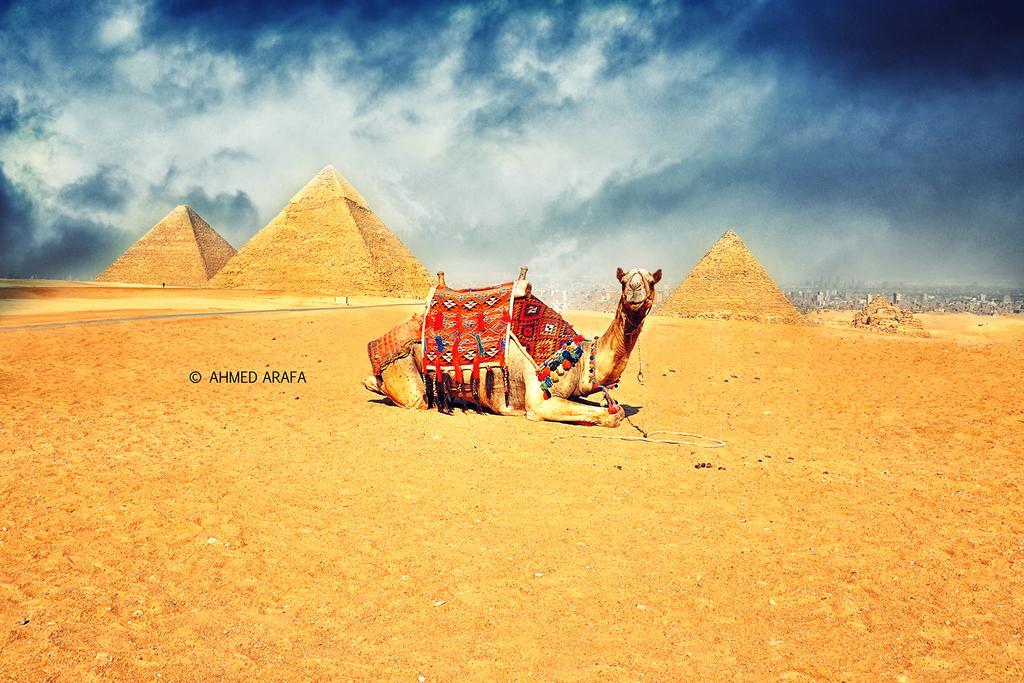Could you give a brief overview of what you see in this image? In this image I see a camel over here and I see the colorful clothes on it and I see the land and in the background I see the pyramids and the sky which is cloudy and I see the watermark over here. 